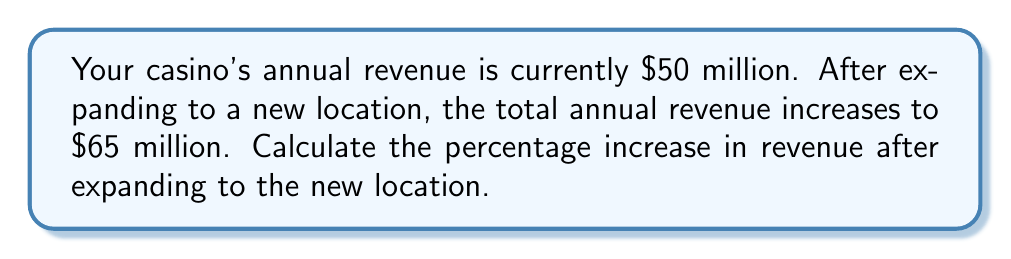Can you answer this question? To calculate the percentage increase in revenue, we'll follow these steps:

1. Find the difference in revenue:
   $$\text{Revenue increase} = \text{New revenue} - \text{Original revenue}$$
   $$\text{Revenue increase} = \$65\text{ million} - \$50\text{ million} = \$15\text{ million}$$

2. Calculate the percentage increase using the formula:
   $$\text{Percentage increase} = \frac{\text{Increase}}{\text{Original value}} \times 100\%$$

3. Substitute the values:
   $$\text{Percentage increase} = \frac{\$15\text{ million}}{\$50\text{ million}} \times 100\%$$

4. Simplify the fraction:
   $$\text{Percentage increase} = \frac{15}{50} \times 100\% = 0.3 \times 100\%$$

5. Calculate the final result:
   $$\text{Percentage increase} = 30\%$$

Therefore, the percentage increase in revenue after expanding to the new location is 30%.
Answer: 30% 